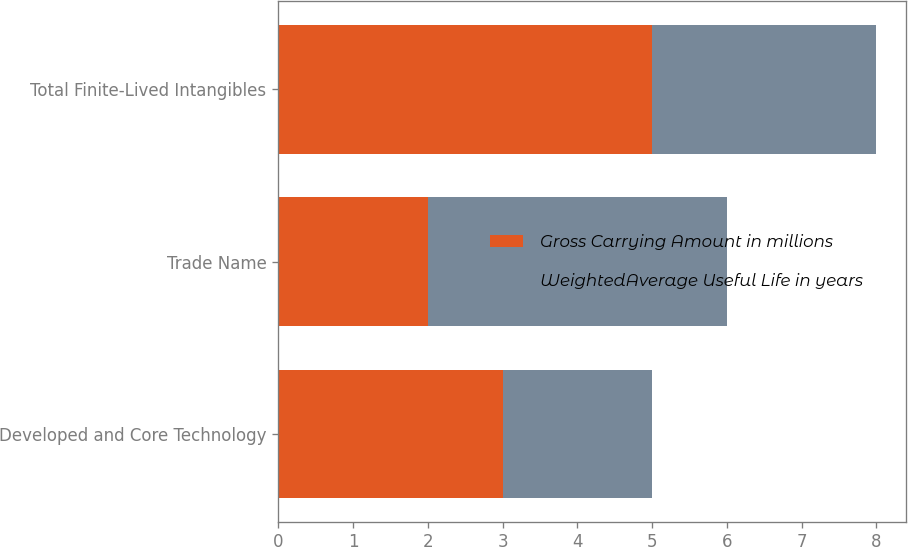<chart> <loc_0><loc_0><loc_500><loc_500><stacked_bar_chart><ecel><fcel>Developed and Core Technology<fcel>Trade Name<fcel>Total Finite-Lived Intangibles<nl><fcel>Gross Carrying Amount in millions<fcel>3<fcel>2<fcel>5<nl><fcel>WeightedAverage Useful Life in years<fcel>2<fcel>4<fcel>3<nl></chart> 